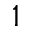Convert formula to latex. <formula><loc_0><loc_0><loc_500><loc_500>^ { 1 }</formula> 